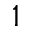Convert formula to latex. <formula><loc_0><loc_0><loc_500><loc_500>^ { 1 }</formula> 